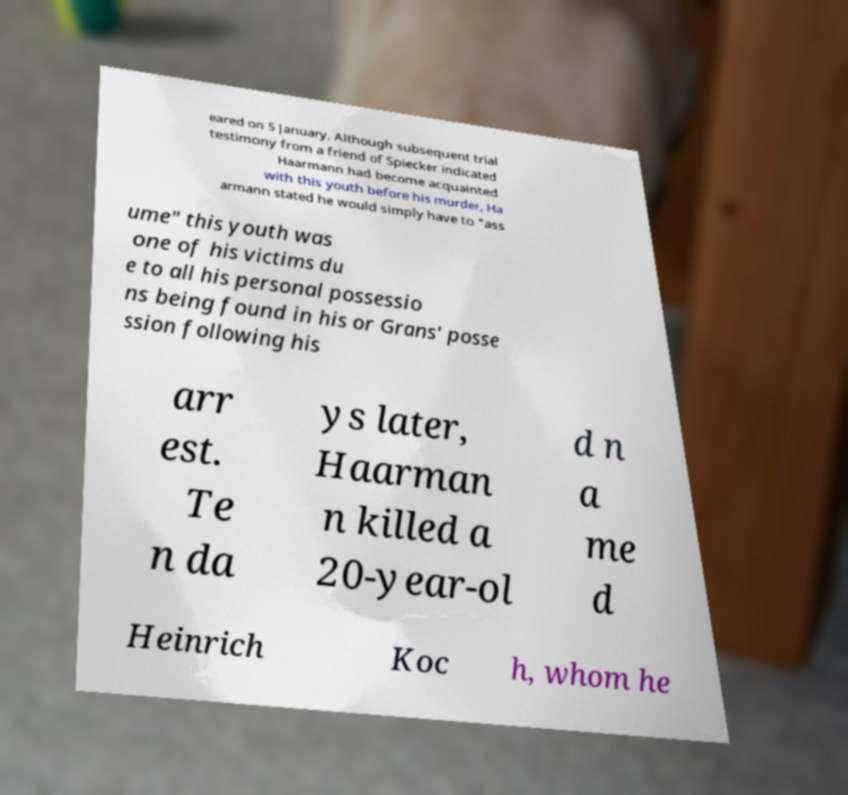For documentation purposes, I need the text within this image transcribed. Could you provide that? eared on 5 January. Although subsequent trial testimony from a friend of Spiecker indicated Haarmann had become acquainted with this youth before his murder, Ha armann stated he would simply have to "ass ume" this youth was one of his victims du e to all his personal possessio ns being found in his or Grans' posse ssion following his arr est. Te n da ys later, Haarman n killed a 20-year-ol d n a me d Heinrich Koc h, whom he 